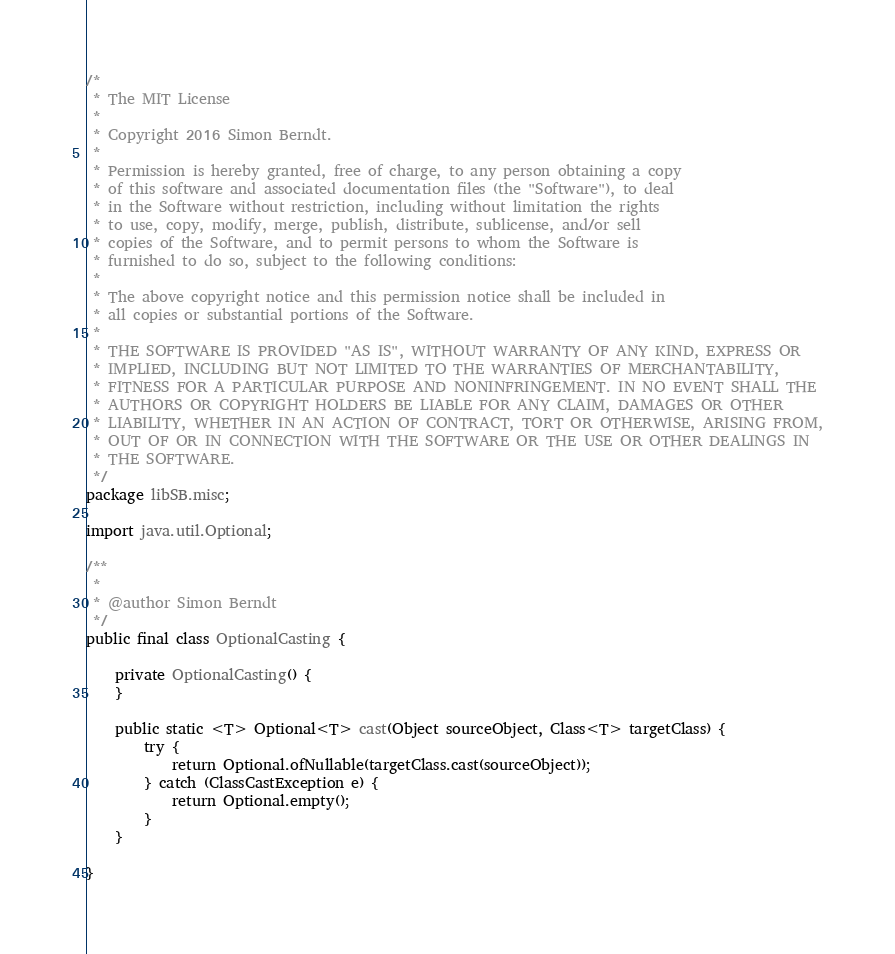Convert code to text. <code><loc_0><loc_0><loc_500><loc_500><_Java_>/* 
 * The MIT License
 *
 * Copyright 2016 Simon Berndt.
 *
 * Permission is hereby granted, free of charge, to any person obtaining a copy
 * of this software and associated documentation files (the "Software"), to deal
 * in the Software without restriction, including without limitation the rights
 * to use, copy, modify, merge, publish, distribute, sublicense, and/or sell
 * copies of the Software, and to permit persons to whom the Software is
 * furnished to do so, subject to the following conditions:
 *
 * The above copyright notice and this permission notice shall be included in
 * all copies or substantial portions of the Software.
 *
 * THE SOFTWARE IS PROVIDED "AS IS", WITHOUT WARRANTY OF ANY KIND, EXPRESS OR
 * IMPLIED, INCLUDING BUT NOT LIMITED TO THE WARRANTIES OF MERCHANTABILITY,
 * FITNESS FOR A PARTICULAR PURPOSE AND NONINFRINGEMENT. IN NO EVENT SHALL THE
 * AUTHORS OR COPYRIGHT HOLDERS BE LIABLE FOR ANY CLAIM, DAMAGES OR OTHER
 * LIABILITY, WHETHER IN AN ACTION OF CONTRACT, TORT OR OTHERWISE, ARISING FROM,
 * OUT OF OR IN CONNECTION WITH THE SOFTWARE OR THE USE OR OTHER DEALINGS IN
 * THE SOFTWARE.
 */
package libSB.misc;

import java.util.Optional;

/**
 *
 * @author Simon Berndt
 */
public final class OptionalCasting {

    private OptionalCasting() {
    }
    
    public static <T> Optional<T> cast(Object sourceObject, Class<T> targetClass) {
        try {
            return Optional.ofNullable(targetClass.cast(sourceObject));
        } catch (ClassCastException e) {
            return Optional.empty();
        }
    }

}
</code> 